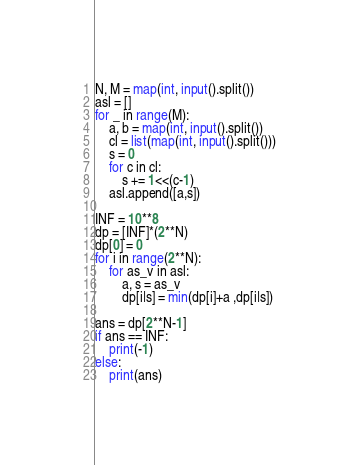<code> <loc_0><loc_0><loc_500><loc_500><_Python_>N, M = map(int, input().split()) 
asl = []
for _ in range(M):
    a, b = map(int, input().split()) 
    cl = list(map(int, input().split())) 
    s = 0
    for c in cl:
        s += 1<<(c-1)
    asl.append([a,s])

INF = 10**8
dp = [INF]*(2**N)
dp[0] = 0
for i in range(2**N):
    for as_v in asl:
        a, s = as_v
        dp[i|s] = min(dp[i]+a ,dp[i|s])

ans = dp[2**N-1]
if ans == INF:
    print(-1)
else:
    print(ans)
</code> 